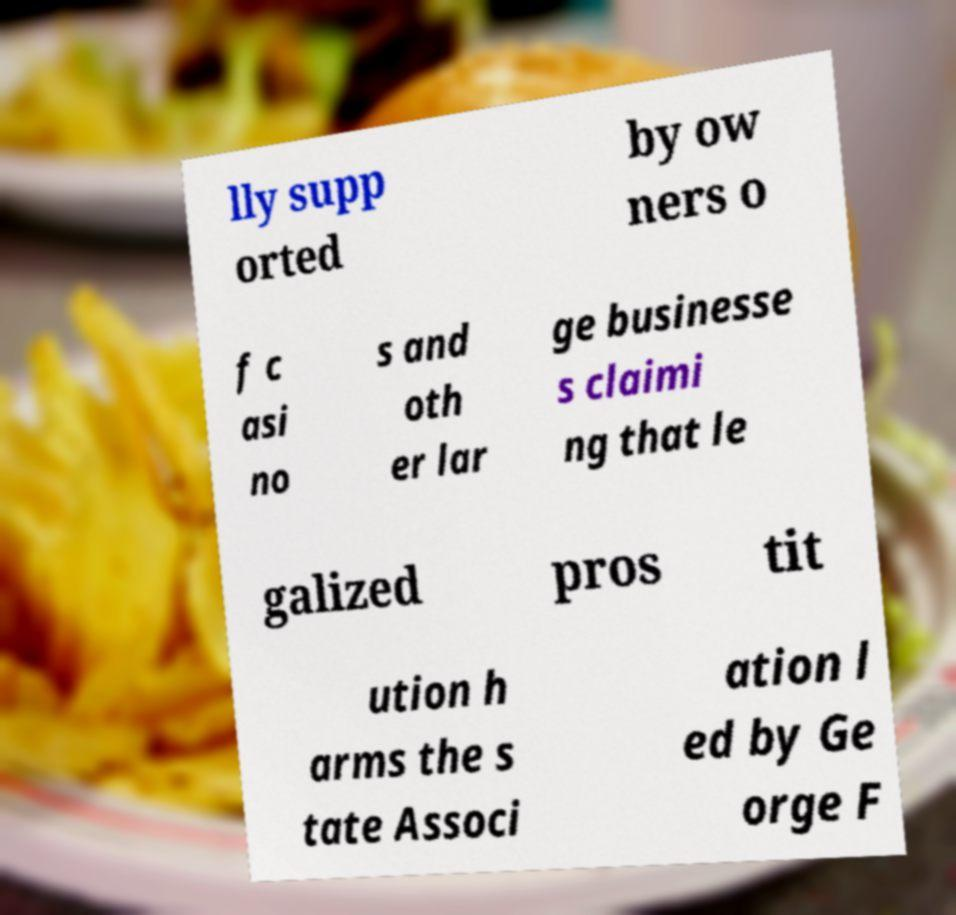There's text embedded in this image that I need extracted. Can you transcribe it verbatim? lly supp orted by ow ners o f c asi no s and oth er lar ge businesse s claimi ng that le galized pros tit ution h arms the s tate Associ ation l ed by Ge orge F 